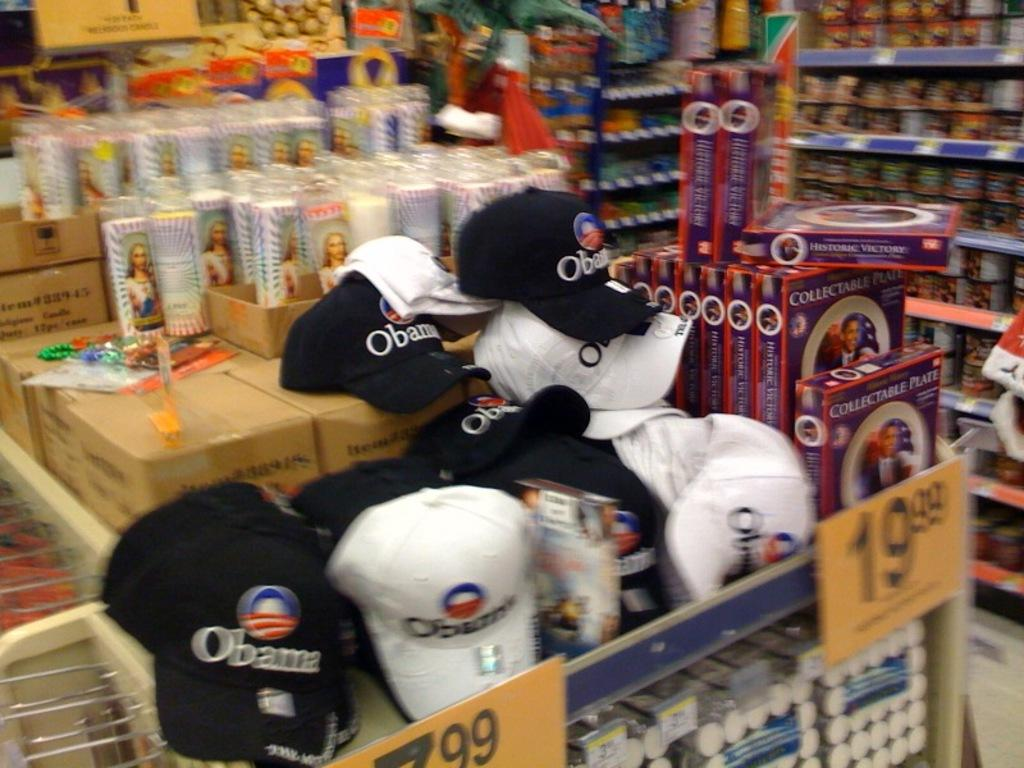<image>
Create a compact narrative representing the image presented. An Obama collectible plate can be purchased in the store for $19.99. 